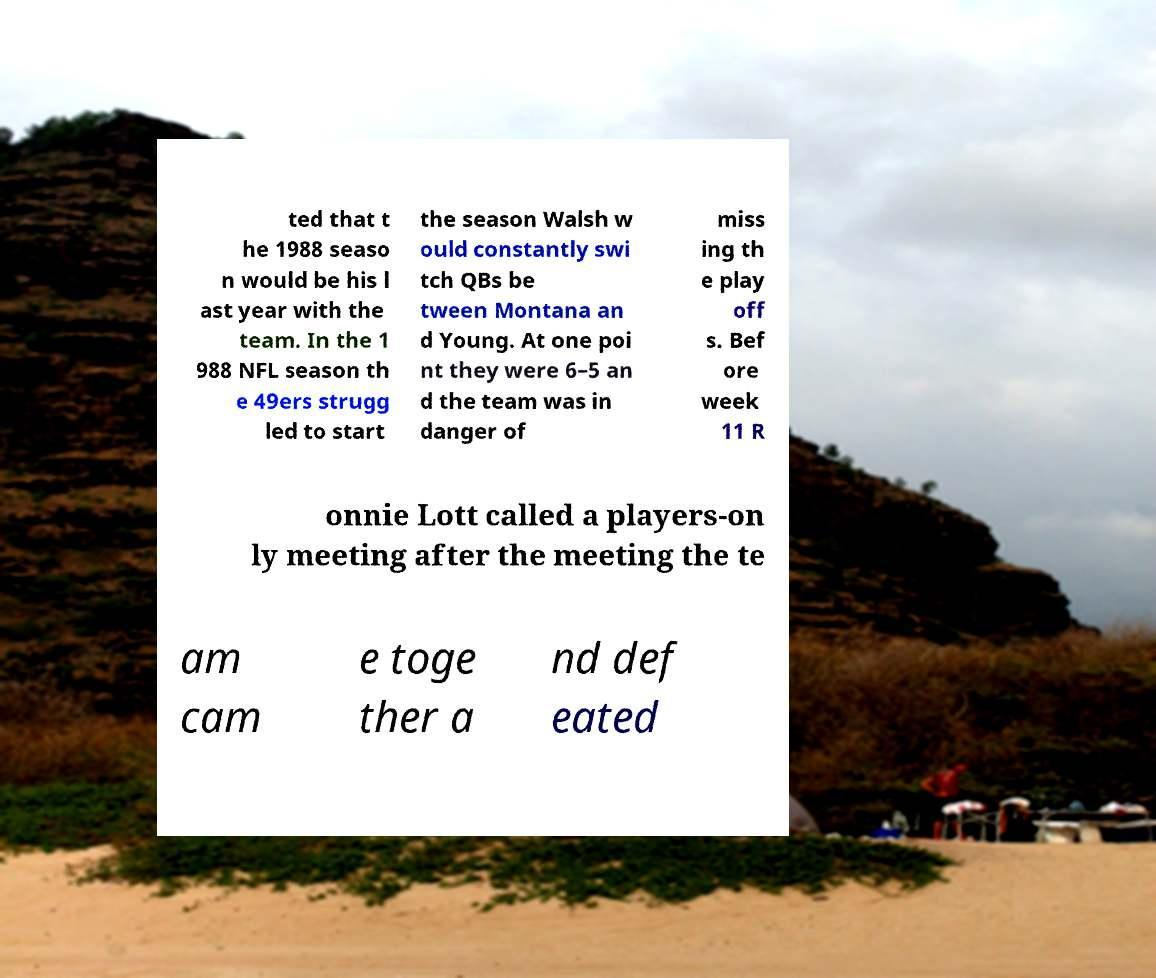Can you accurately transcribe the text from the provided image for me? ted that t he 1988 seaso n would be his l ast year with the team. In the 1 988 NFL season th e 49ers strugg led to start the season Walsh w ould constantly swi tch QBs be tween Montana an d Young. At one poi nt they were 6–5 an d the team was in danger of miss ing th e play off s. Bef ore week 11 R onnie Lott called a players-on ly meeting after the meeting the te am cam e toge ther a nd def eated 